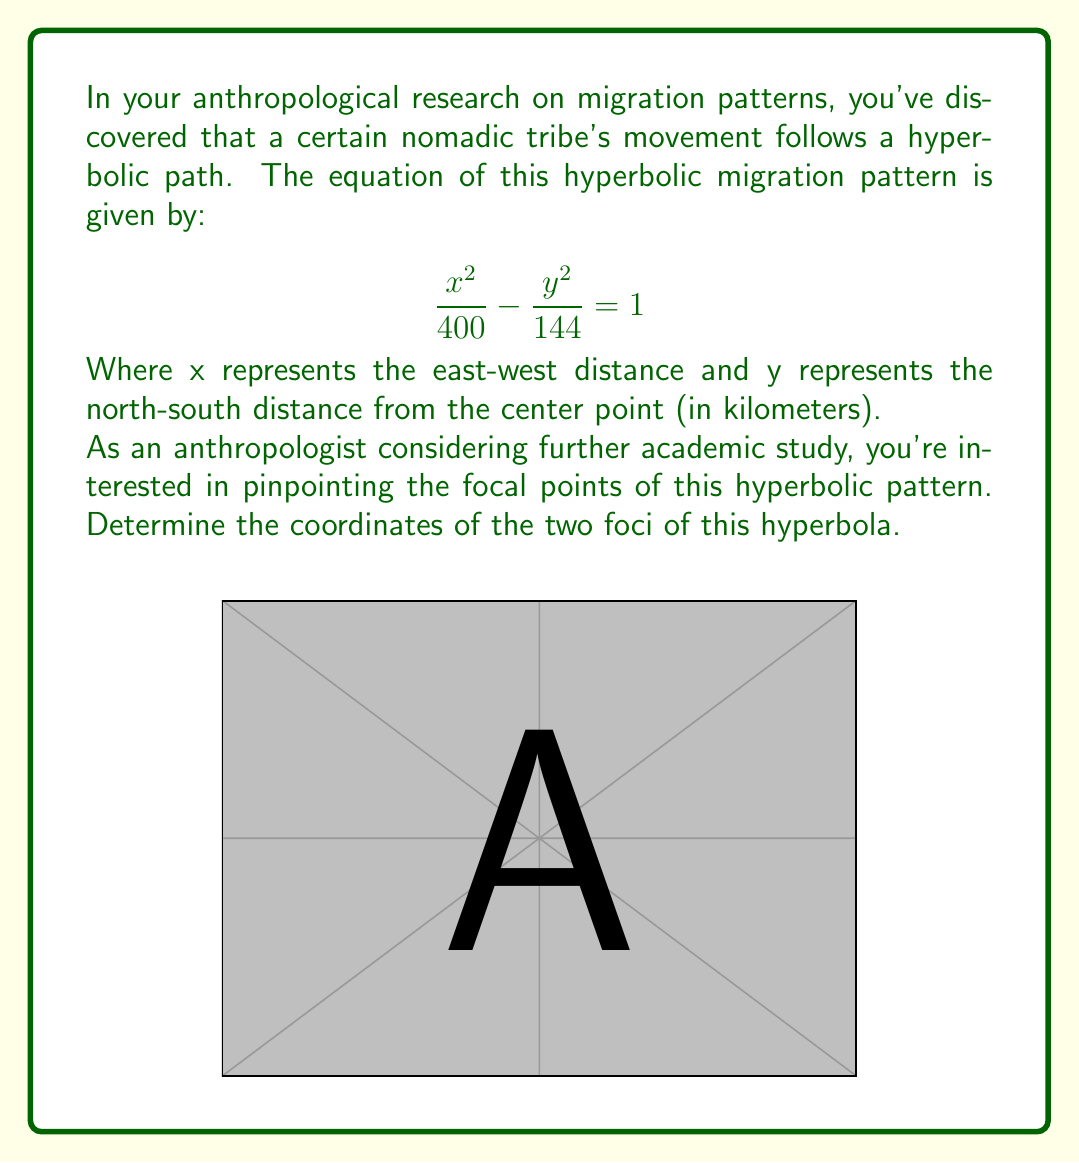Help me with this question. Let's approach this step-by-step:

1) The standard form of a hyperbola with center at the origin is:

   $$\frac{x^2}{a^2} - \frac{y^2}{b^2} = 1$$

   Where $a$ is the distance from the center to the vertex, and $b$ is the distance from the center to the co-vertex.

2) Comparing our equation to the standard form, we can see that:
   
   $a^2 = 400$, so $a = 20$
   $b^2 = 144$, so $b = 12$

3) For a hyperbola, the distance $c$ from the center to a focus is given by:

   $$c^2 = a^2 + b^2$$

4) Let's calculate $c$:

   $$c^2 = 400 + 144 = 544$$
   $$c = \sqrt{544} = 4\sqrt{34} \approx 23.32$$

5) Since the hyperbola is centered at the origin and opens along the x-axis (because the $x^2$ term is positive), the foci will be on the x-axis at $\pm c$.

6) Therefore, the coordinates of the foci are:

   $F_1 = (4\sqrt{34}, 0)$ and $F_2 = (-4\sqrt{34}, 0)$
Answer: $(4\sqrt{34}, 0)$ and $(-4\sqrt{34}, 0)$ 